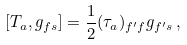<formula> <loc_0><loc_0><loc_500><loc_500>\left [ T _ { a } , g _ { f s } \right ] = \frac { 1 } { 2 } ( \tau _ { a } ) _ { f ^ { \prime } f } g _ { f ^ { \prime } s } \, ,</formula> 